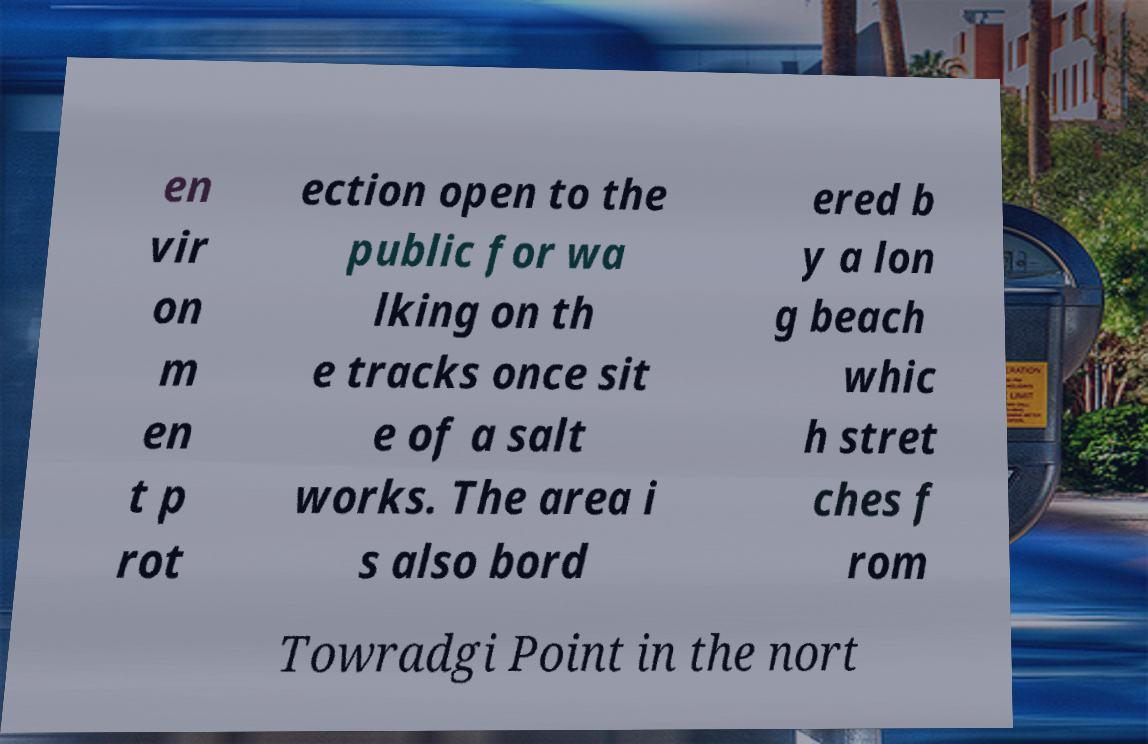I need the written content from this picture converted into text. Can you do that? en vir on m en t p rot ection open to the public for wa lking on th e tracks once sit e of a salt works. The area i s also bord ered b y a lon g beach whic h stret ches f rom Towradgi Point in the nort 